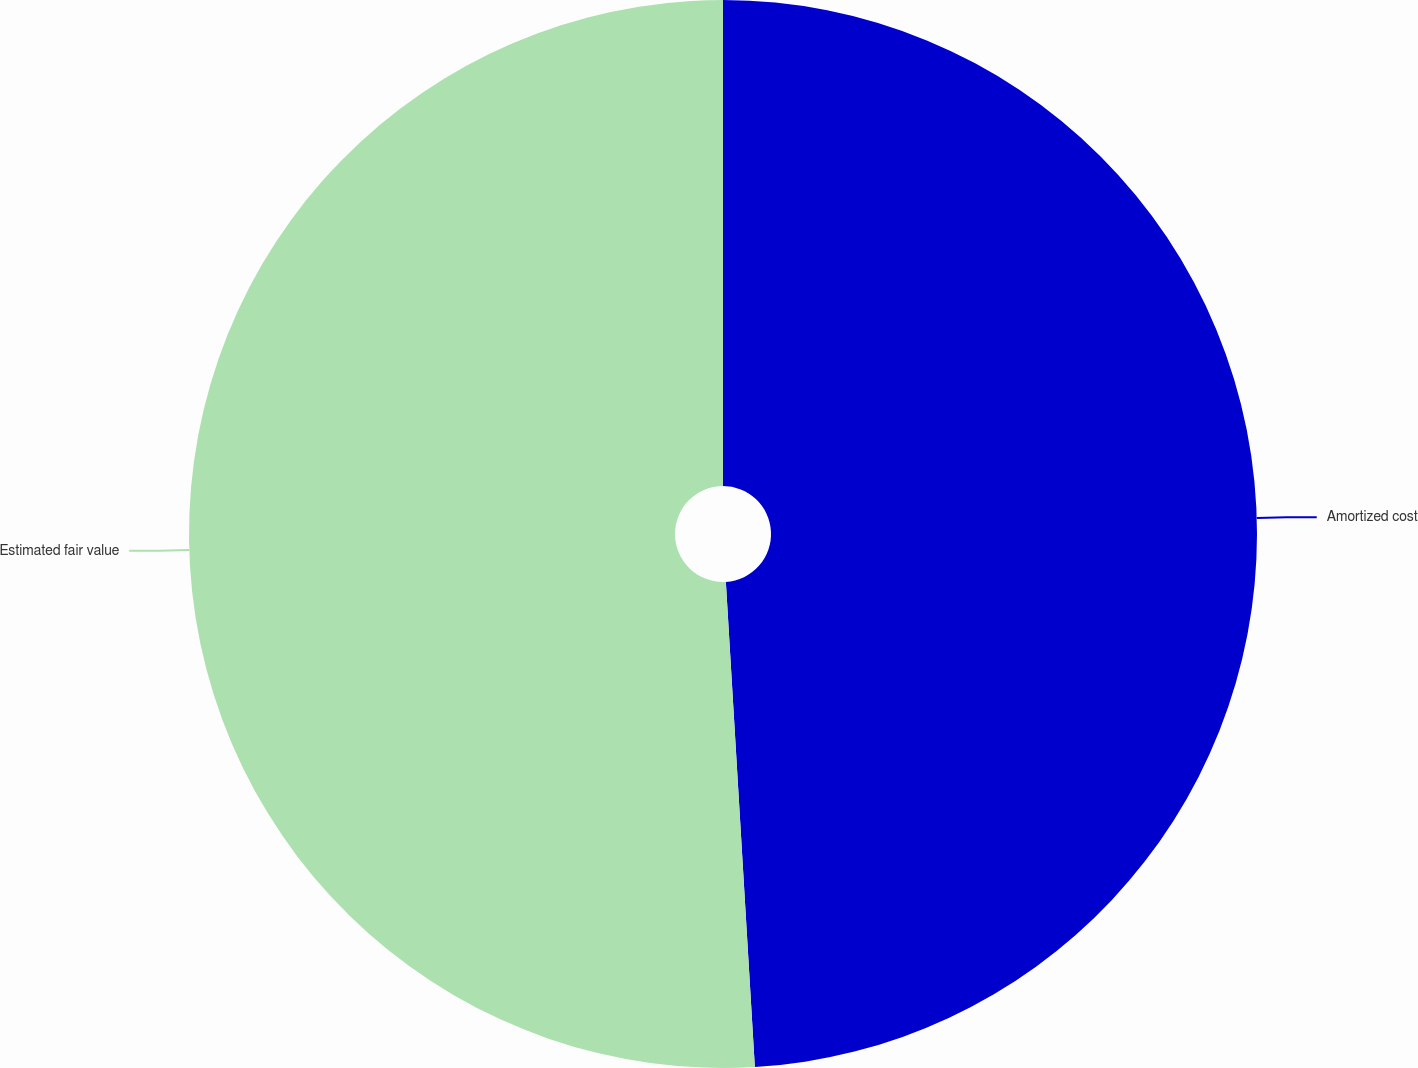Convert chart. <chart><loc_0><loc_0><loc_500><loc_500><pie_chart><fcel>Amortized cost<fcel>Estimated fair value<nl><fcel>49.05%<fcel>50.95%<nl></chart> 